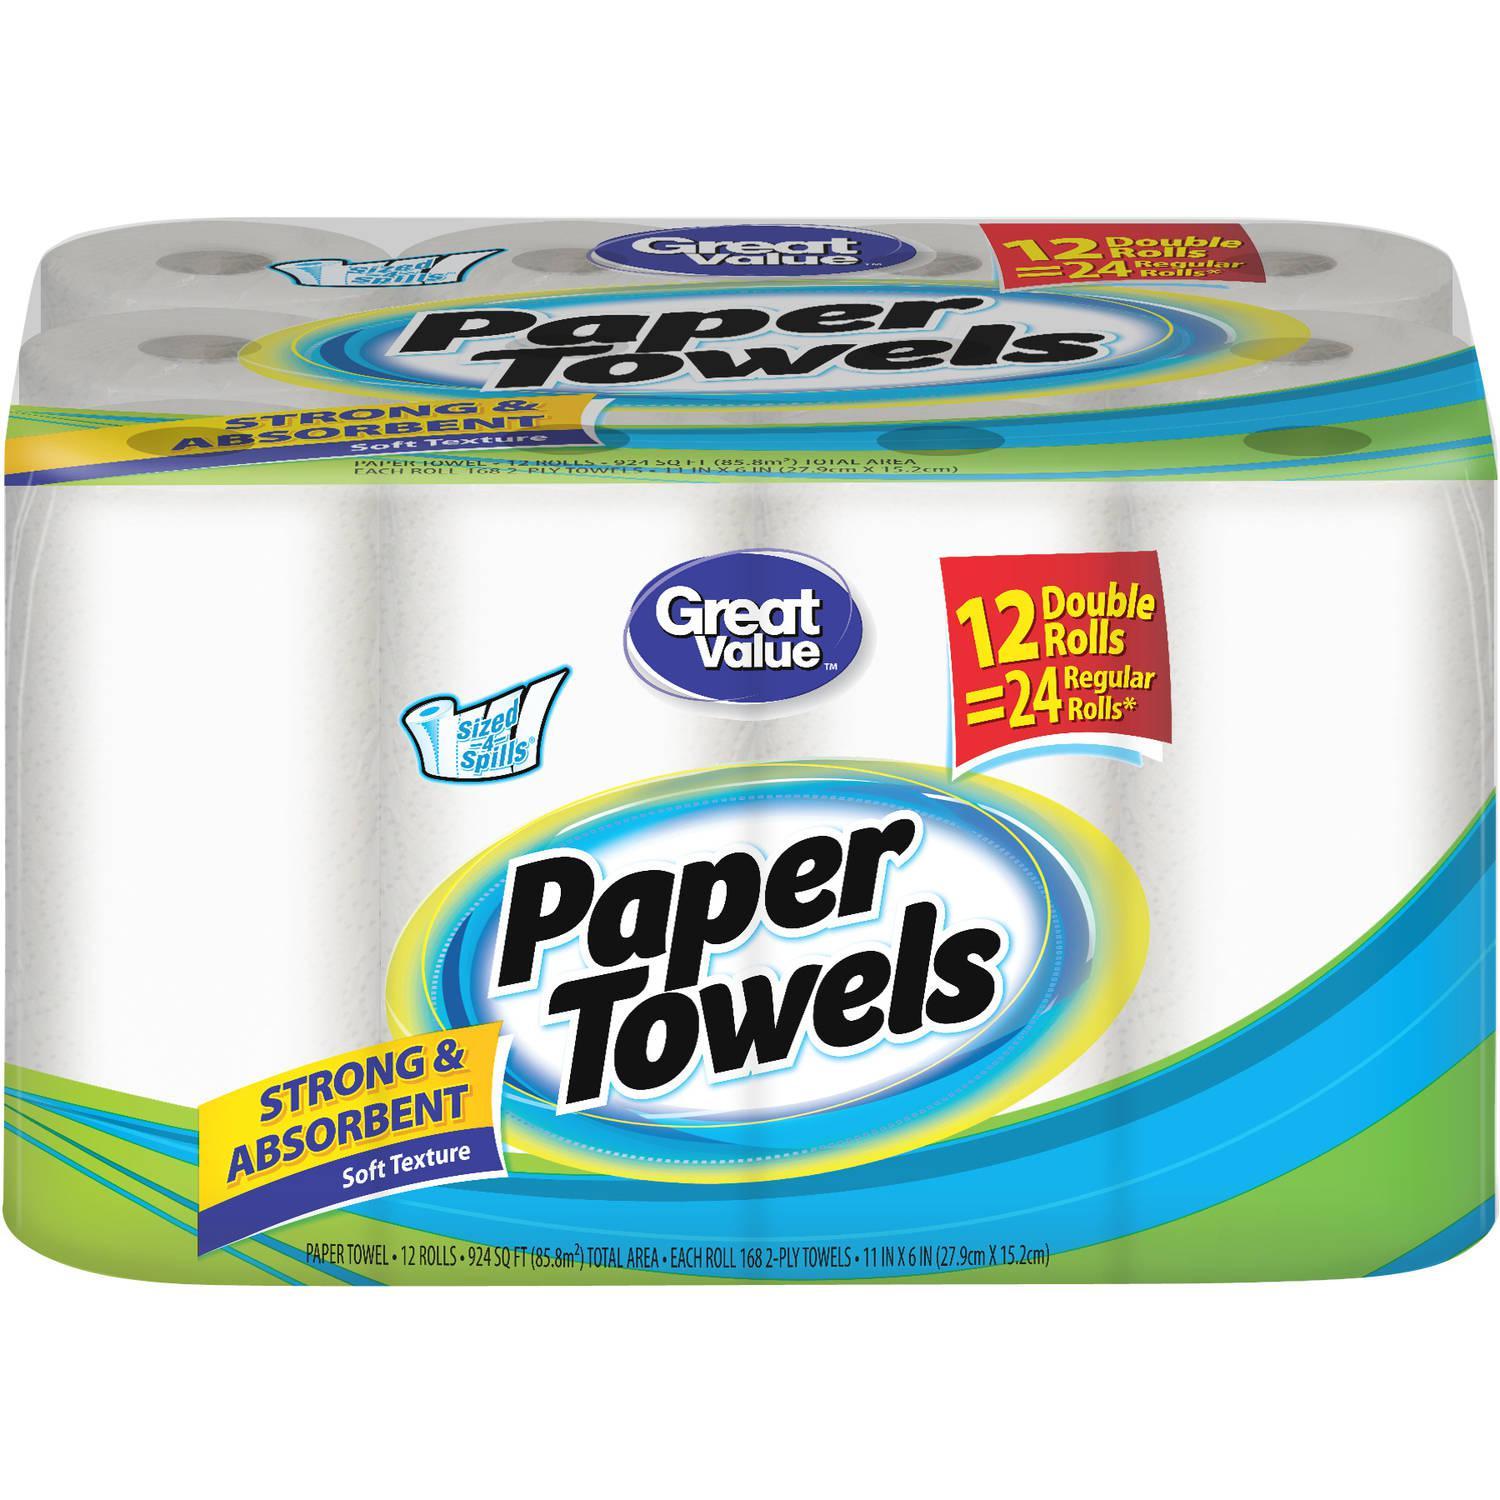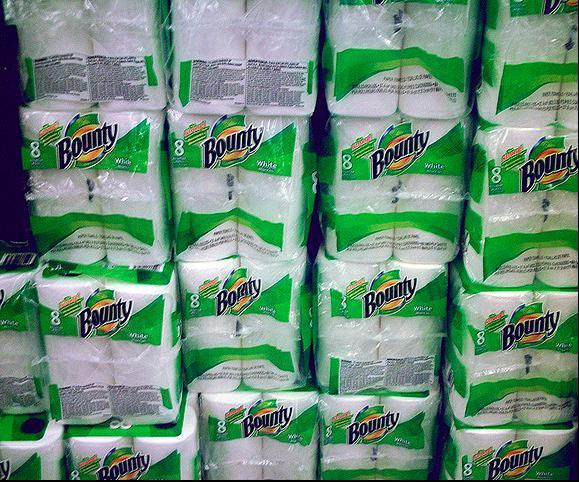The first image is the image on the left, the second image is the image on the right. For the images displayed, is the sentence "A single package of paper towels stands alone in the image on the left." factually correct? Answer yes or no. Yes. The first image is the image on the left, the second image is the image on the right. Analyze the images presented: Is the assertion "The left-hand image shows exactly one multi-pack of paper towels." valid? Answer yes or no. Yes. 